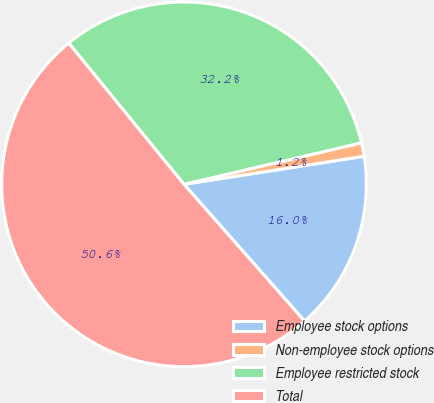Convert chart to OTSL. <chart><loc_0><loc_0><loc_500><loc_500><pie_chart><fcel>Employee stock options<fcel>Non-employee stock options<fcel>Employee restricted stock<fcel>Total<nl><fcel>15.96%<fcel>1.2%<fcel>32.23%<fcel>50.6%<nl></chart> 